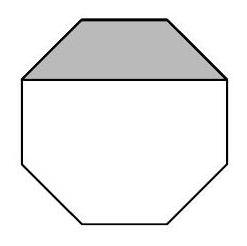What is the significance of the shape of the line drawn across the octagon? The line drawn across the octagon likely connects two vertices directly opposite each other. This not only divides the octagon into two equal parts but also plays a critical role in understanding its symmetry and geometric properties. Such lines can help in establishing relationships between different sections of the shape, useful in area distribution or analyzing the angles and sides. 